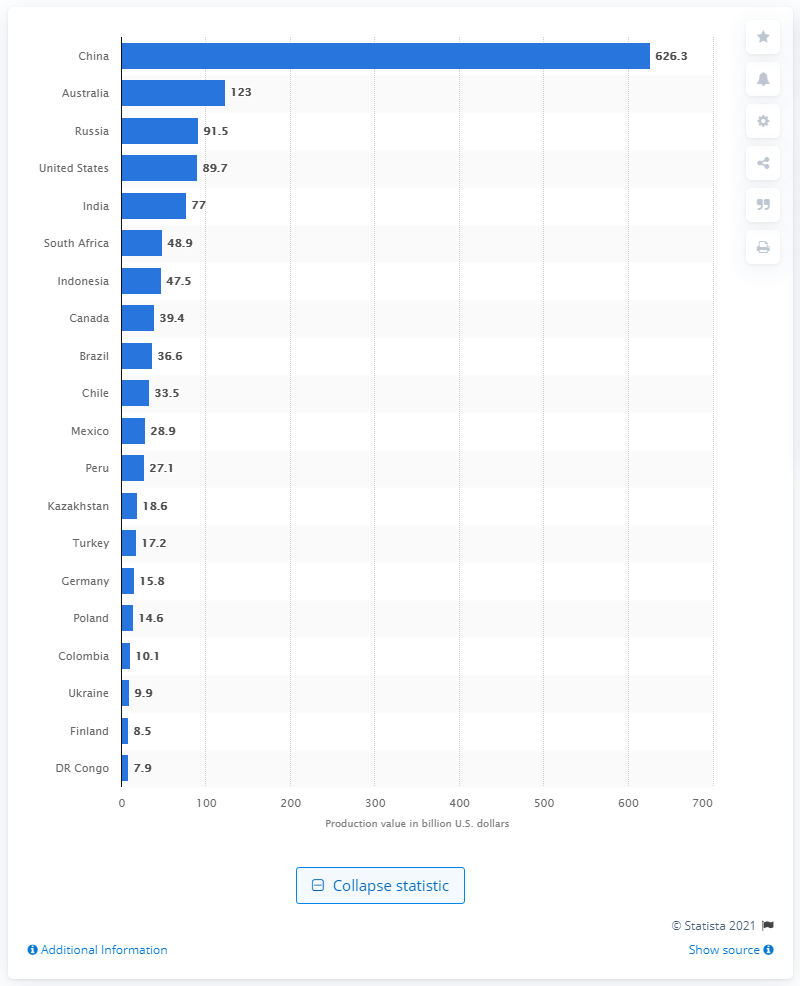Point out several critical features in this image. In 2016, the United States spent $89.7 billion in mineral production value. In 2016, China's mineral production value was estimated to be approximately 626.3 billion U.S. dollars. 